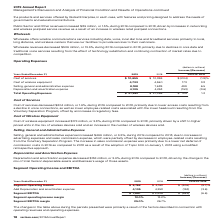According to Verizon Communications's financial document, How much was the Cost of services in 2019? According to the financial document, $10,655 (in millions). The relevant text states: "Cost of services $ 10,655 $ 10,859 $ (204) (1.9)%..." Also, How much was the Cost of Wireless Equipment in 2019? According to the financial document, 4,733 (in millions). The relevant text states: "Cost of wireless equipment 4,733 4,560 173 3.8..." Also, How much was the Selling, General and Administrative Expense in 2019? According to the financial document, 8,188 (in millions). The relevant text states: "Selling, general and administrative expense 8,188 7,689 499 6.5..." Also, can you calculate: What is the change in Cost of services from 2018 to 2019? Based on the calculation: 10,655-10,859, the result is -204 (in millions). This is based on the information: "Cost of services $ 10,655 $ 10,859 $ (204) (1.9)% Cost of services $ 10,655 $ 10,859 $ (204) (1.9)%..." The key data points involved are: 10,655, 10,859. Also, can you calculate: What is the change in Cost of wireless equipment from 2018 to 2019? Based on the calculation: 4,733-4,560, the result is 173 (in millions). This is based on the information: "Cost of wireless equipment 4,733 4,560 173 3.8 Cost of wireless equipment 4,733 4,560 173 3.8..." The key data points involved are: 4,560, 4,733. Also, can you calculate: What is the change in Selling, general and administrative expense from 2018 to 2019? Based on the calculation: 8,188-7,689, the result is 499 (in millions). This is based on the information: "Selling, general and administrative expense 8,188 7,689 499 6.5 Selling, general and administrative expense 8,188 7,689 499 6.5..." The key data points involved are: 7,689, 8,188. 